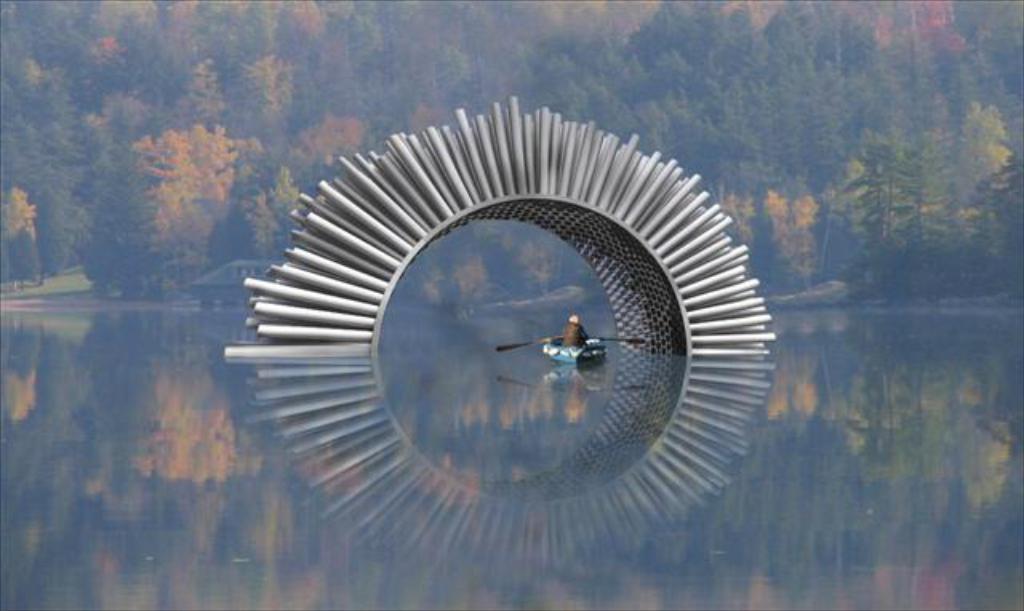Please provide a concise description of this image. In-between of this water there is an arch. Person is on boat. Far there are trees. 